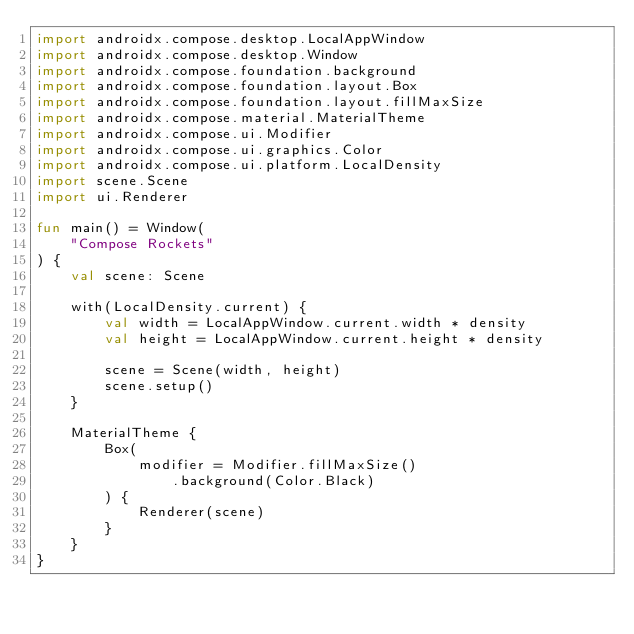Convert code to text. <code><loc_0><loc_0><loc_500><loc_500><_Kotlin_>import androidx.compose.desktop.LocalAppWindow
import androidx.compose.desktop.Window
import androidx.compose.foundation.background
import androidx.compose.foundation.layout.Box
import androidx.compose.foundation.layout.fillMaxSize
import androidx.compose.material.MaterialTheme
import androidx.compose.ui.Modifier
import androidx.compose.ui.graphics.Color
import androidx.compose.ui.platform.LocalDensity
import scene.Scene
import ui.Renderer

fun main() = Window(
    "Compose Rockets"
) {
    val scene: Scene

    with(LocalDensity.current) {
        val width = LocalAppWindow.current.width * density
        val height = LocalAppWindow.current.height * density

        scene = Scene(width, height)
        scene.setup()
    }

    MaterialTheme {
        Box(
            modifier = Modifier.fillMaxSize()
                .background(Color.Black)
        ) {
            Renderer(scene)
        }
    }
}
</code> 